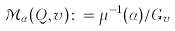Convert formula to latex. <formula><loc_0><loc_0><loc_500><loc_500>\mathcal { M } _ { \alpha } ( Q , { v } ) \colon = \mu ^ { - 1 } ( \alpha ) / G _ { v }</formula> 